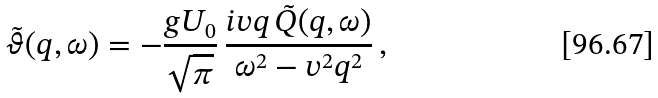Convert formula to latex. <formula><loc_0><loc_0><loc_500><loc_500>\tilde { \vartheta } ( q , \omega ) = - \frac { g U _ { 0 } } { \sqrt { \pi } } \, \frac { i v q \, \tilde { Q } ( q , \omega ) } { \omega ^ { 2 } - v ^ { 2 } q ^ { 2 } } \, ,</formula> 